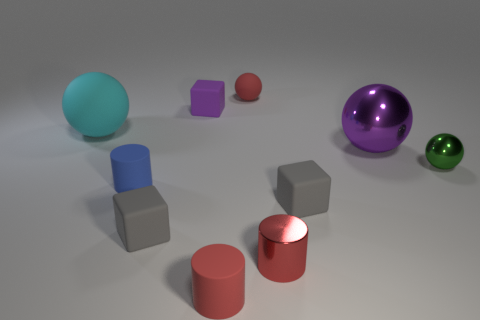Is there a pattern in the arrangement of the objects? There doesn't seem to be a strict pattern, but the objects are spaced out evenly across the surface, suggesting a deliberate placement without any particular order or sequence.  What can you infer about the texture of the objects? The objects appear to have smooth textures with a matte finish, except for the large purple sphere and the red cylinder, which seem to have a reflective, glossy surface. 